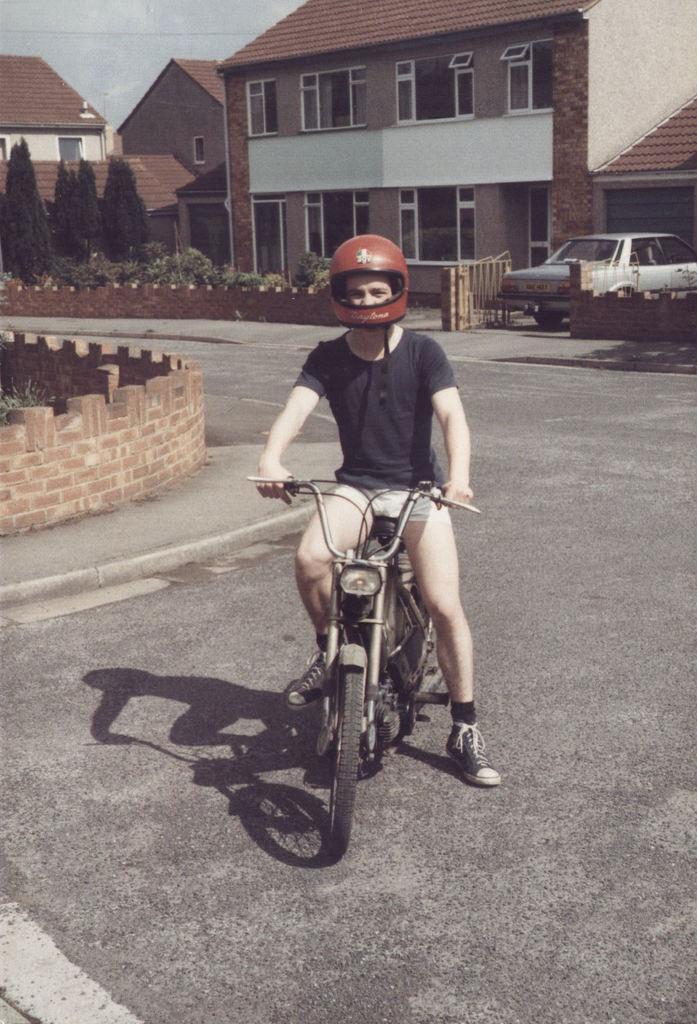How would you summarize this image in a sentence or two? In this picture a guy who is wearing a helmet and sitting on a old bike. In the background there is a vehicle and few small houses. There are also trees in the background. 